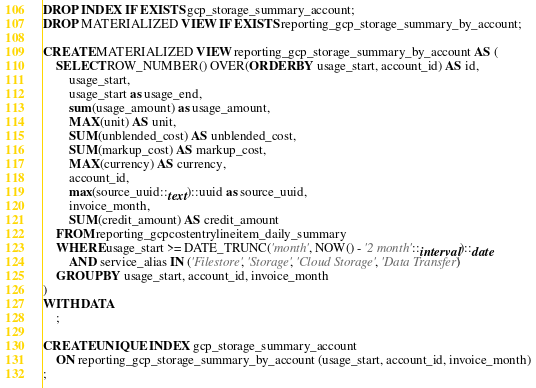Convert code to text. <code><loc_0><loc_0><loc_500><loc_500><_SQL_>DROP INDEX IF EXISTS gcp_storage_summary_account;
DROP MATERIALIZED VIEW IF EXISTS reporting_gcp_storage_summary_by_account;

CREATE MATERIALIZED VIEW reporting_gcp_storage_summary_by_account AS (
    SELECT ROW_NUMBER() OVER(ORDER BY usage_start, account_id) AS id,
        usage_start,
        usage_start as usage_end,
        sum(usage_amount) as usage_amount,
        MAX(unit) AS unit,
        SUM(unblended_cost) AS unblended_cost,
        SUM(markup_cost) AS markup_cost,
        MAX(currency) AS currency,
        account_id,
        max(source_uuid::text)::uuid as source_uuid,
        invoice_month,
        SUM(credit_amount) AS credit_amount
    FROM reporting_gcpcostentrylineitem_daily_summary
    WHERE usage_start >= DATE_TRUNC('month', NOW() - '2 month'::interval)::date
        AND service_alias IN ('Filestore', 'Storage', 'Cloud Storage', 'Data Transfer')
    GROUP BY usage_start, account_id, invoice_month
)
WITH DATA
    ;

CREATE UNIQUE INDEX gcp_storage_summary_account
    ON reporting_gcp_storage_summary_by_account (usage_start, account_id, invoice_month)
;
</code> 